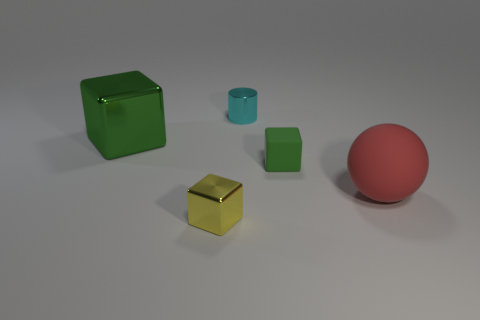Add 3 tiny matte things. How many objects exist? 8 Subtract all balls. How many objects are left? 4 Subtract all big green blocks. Subtract all tiny green matte things. How many objects are left? 3 Add 4 red spheres. How many red spheres are left? 5 Add 3 big gray rubber things. How many big gray rubber things exist? 3 Subtract 0 gray spheres. How many objects are left? 5 